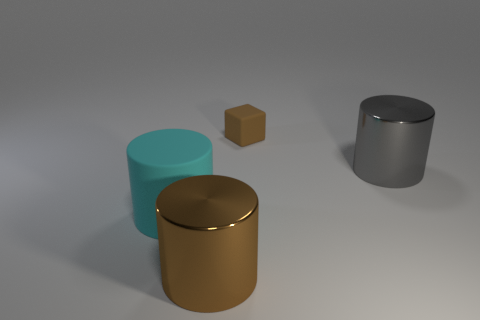Subtract all cyan cylinders. How many cylinders are left? 2 Add 4 big green things. How many objects exist? 8 Subtract all cylinders. How many objects are left? 1 Subtract 1 cyan cylinders. How many objects are left? 3 Subtract all yellow cylinders. Subtract all red spheres. How many cylinders are left? 3 Subtract all large yellow cylinders. Subtract all cyan cylinders. How many objects are left? 3 Add 4 big matte things. How many big matte things are left? 5 Add 1 big gray cylinders. How many big gray cylinders exist? 2 